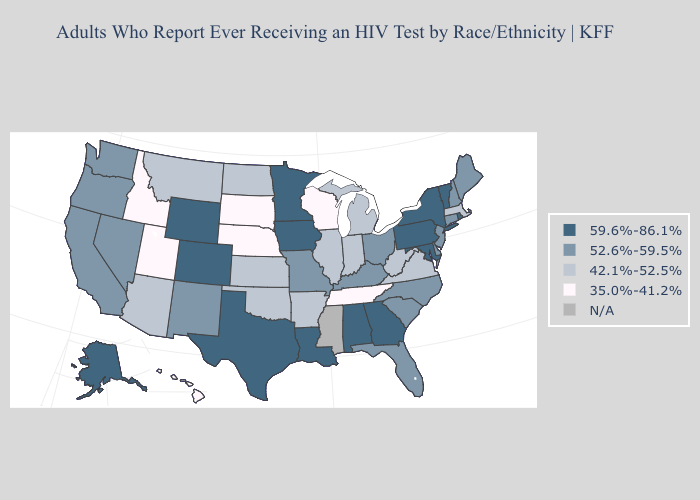Name the states that have a value in the range N/A?
Be succinct. Mississippi. Name the states that have a value in the range 59.6%-86.1%?
Quick response, please. Alabama, Alaska, Colorado, Georgia, Iowa, Louisiana, Maryland, Minnesota, New York, Pennsylvania, Rhode Island, Texas, Vermont, Wyoming. Does Virginia have the highest value in the South?
Keep it brief. No. Which states have the highest value in the USA?
Give a very brief answer. Alabama, Alaska, Colorado, Georgia, Iowa, Louisiana, Maryland, Minnesota, New York, Pennsylvania, Rhode Island, Texas, Vermont, Wyoming. Is the legend a continuous bar?
Be succinct. No. What is the value of Georgia?
Quick response, please. 59.6%-86.1%. What is the lowest value in the MidWest?
Quick response, please. 35.0%-41.2%. Name the states that have a value in the range 59.6%-86.1%?
Write a very short answer. Alabama, Alaska, Colorado, Georgia, Iowa, Louisiana, Maryland, Minnesota, New York, Pennsylvania, Rhode Island, Texas, Vermont, Wyoming. What is the value of Illinois?
Give a very brief answer. 42.1%-52.5%. Name the states that have a value in the range 59.6%-86.1%?
Quick response, please. Alabama, Alaska, Colorado, Georgia, Iowa, Louisiana, Maryland, Minnesota, New York, Pennsylvania, Rhode Island, Texas, Vermont, Wyoming. Which states have the lowest value in the USA?
Keep it brief. Hawaii, Idaho, Nebraska, South Dakota, Tennessee, Utah, Wisconsin. What is the highest value in the MidWest ?
Write a very short answer. 59.6%-86.1%. What is the lowest value in the Northeast?
Short answer required. 42.1%-52.5%. What is the highest value in the South ?
Answer briefly. 59.6%-86.1%. 